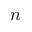Convert formula to latex. <formula><loc_0><loc_0><loc_500><loc_500>n</formula> 